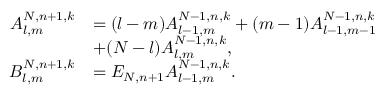Convert formula to latex. <formula><loc_0><loc_0><loc_500><loc_500>\begin{array} { r l } { A _ { l , m } ^ { N , n + 1 , k } } & { = ( l - m ) A _ { l - 1 , m } ^ { N - 1 , n , k } + ( m - 1 ) A _ { l - 1 , m - 1 } ^ { N - 1 , n , k } } \\ & { + ( N - l ) A _ { l , m } ^ { N - 1 , n , k } , } \\ { B _ { l , m } ^ { N , n + 1 , k } } & { = E _ { N , n + 1 } A _ { l - 1 , m } ^ { N - 1 , n , k } . } \end{array}</formula> 